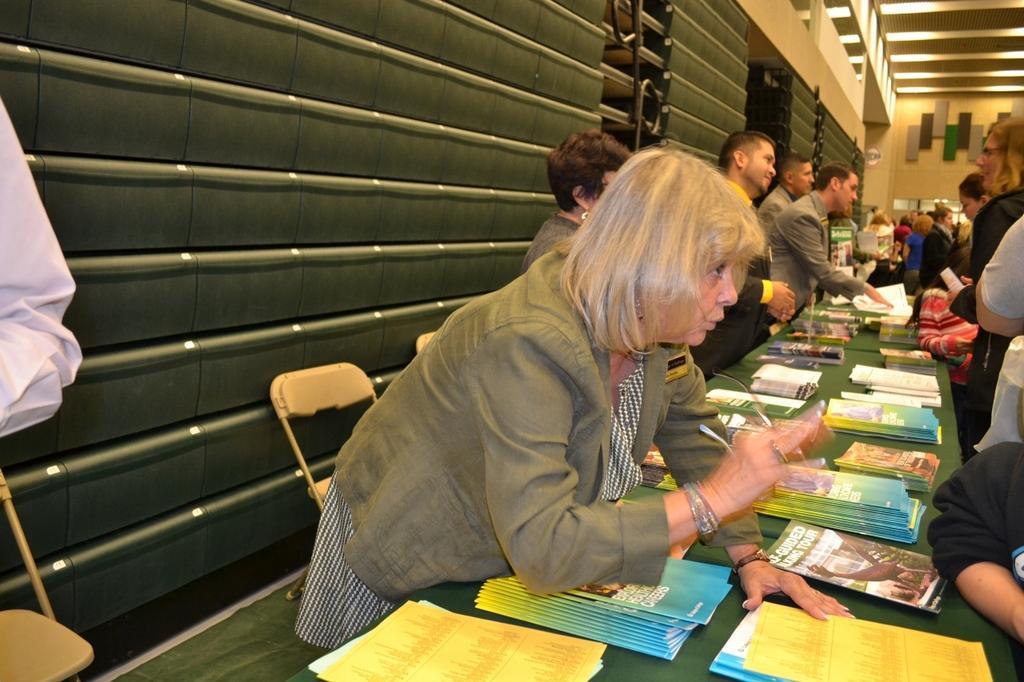In one or two sentences, can you explain what this image depicts? In this image we can see a few people, there are books, and papers on the tables, there are lights, also we can see some objects on the wall. 